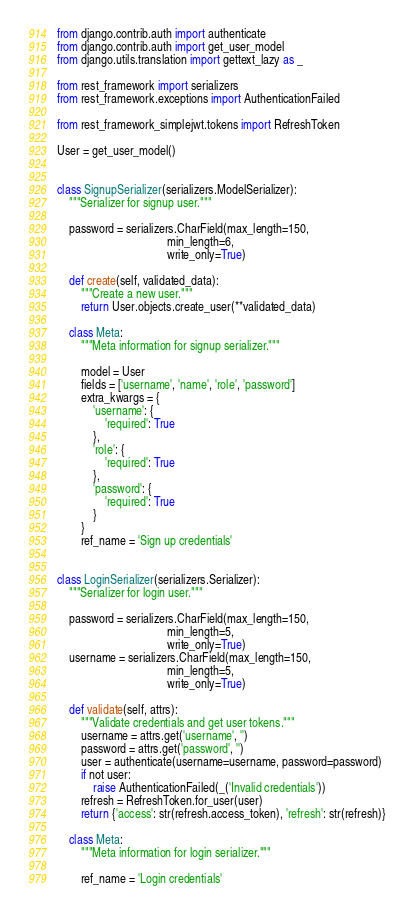Convert code to text. <code><loc_0><loc_0><loc_500><loc_500><_Python_>from django.contrib.auth import authenticate
from django.contrib.auth import get_user_model
from django.utils.translation import gettext_lazy as _

from rest_framework import serializers
from rest_framework.exceptions import AuthenticationFailed

from rest_framework_simplejwt.tokens import RefreshToken

User = get_user_model()


class SignupSerializer(serializers.ModelSerializer):
    """Serializer for signup user."""

    password = serializers.CharField(max_length=150,
                                     min_length=6,
                                     write_only=True)

    def create(self, validated_data):
        """Create a new user."""
        return User.objects.create_user(**validated_data)

    class Meta:
        """Meta information for signup serializer."""

        model = User
        fields = ['username', 'name', 'role', 'password']
        extra_kwargs = {
            'username': {
                'required': True
            },
            'role': {
                'required': True
            },
            'password': {
                'required': True
            }
        }
        ref_name = 'Sign up credentials'


class LoginSerializer(serializers.Serializer):
    """Serializer for login user."""

    password = serializers.CharField(max_length=150,
                                     min_length=5,
                                     write_only=True)
    username = serializers.CharField(max_length=150,
                                     min_length=5,
                                     write_only=True)

    def validate(self, attrs):
        """Validate credentials and get user tokens."""
        username = attrs.get('username', '')
        password = attrs.get('password', '')
        user = authenticate(username=username, password=password)
        if not user:
            raise AuthenticationFailed(_('Invalid credentials'))
        refresh = RefreshToken.for_user(user)
        return {'access': str(refresh.access_token), 'refresh': str(refresh)}

    class Meta:
        """Meta information for login serializer."""

        ref_name = 'Login credentials'
</code> 